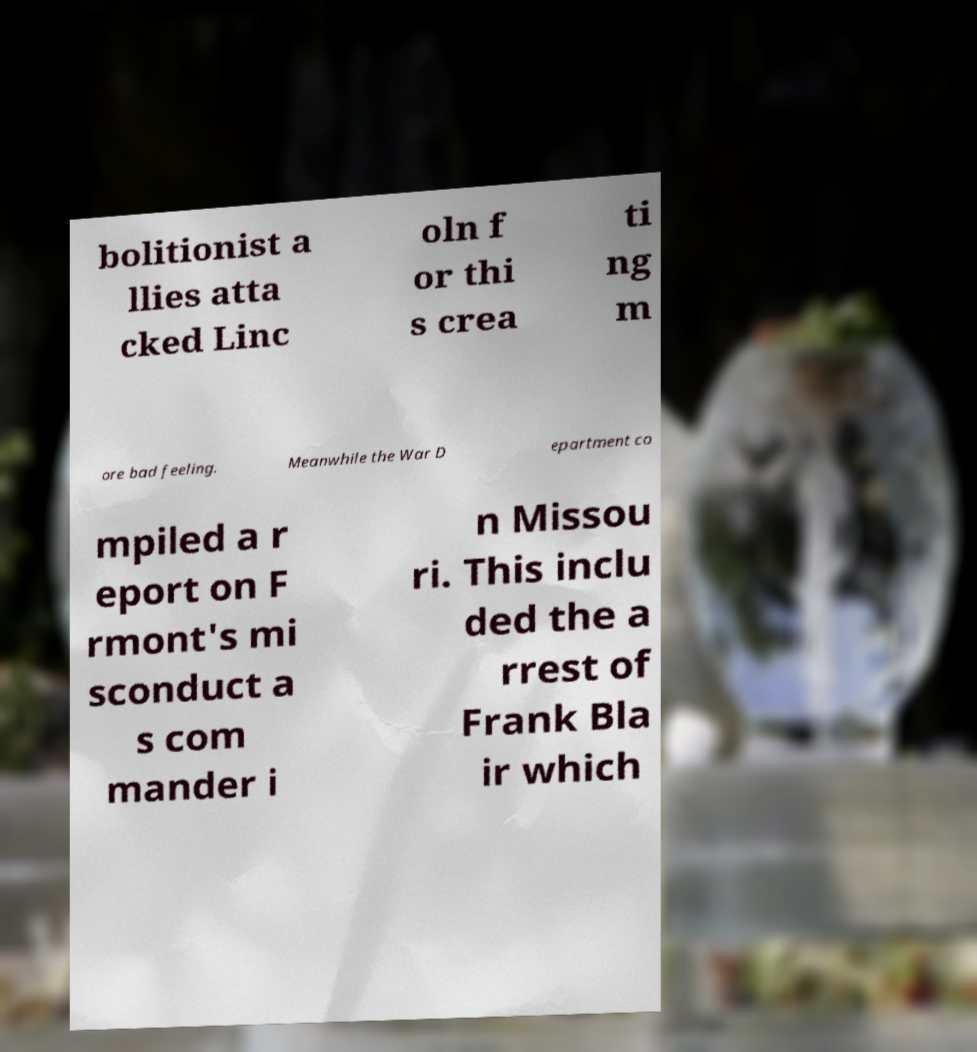For documentation purposes, I need the text within this image transcribed. Could you provide that? bolitionist a llies atta cked Linc oln f or thi s crea ti ng m ore bad feeling. Meanwhile the War D epartment co mpiled a r eport on F rmont's mi sconduct a s com mander i n Missou ri. This inclu ded the a rrest of Frank Bla ir which 